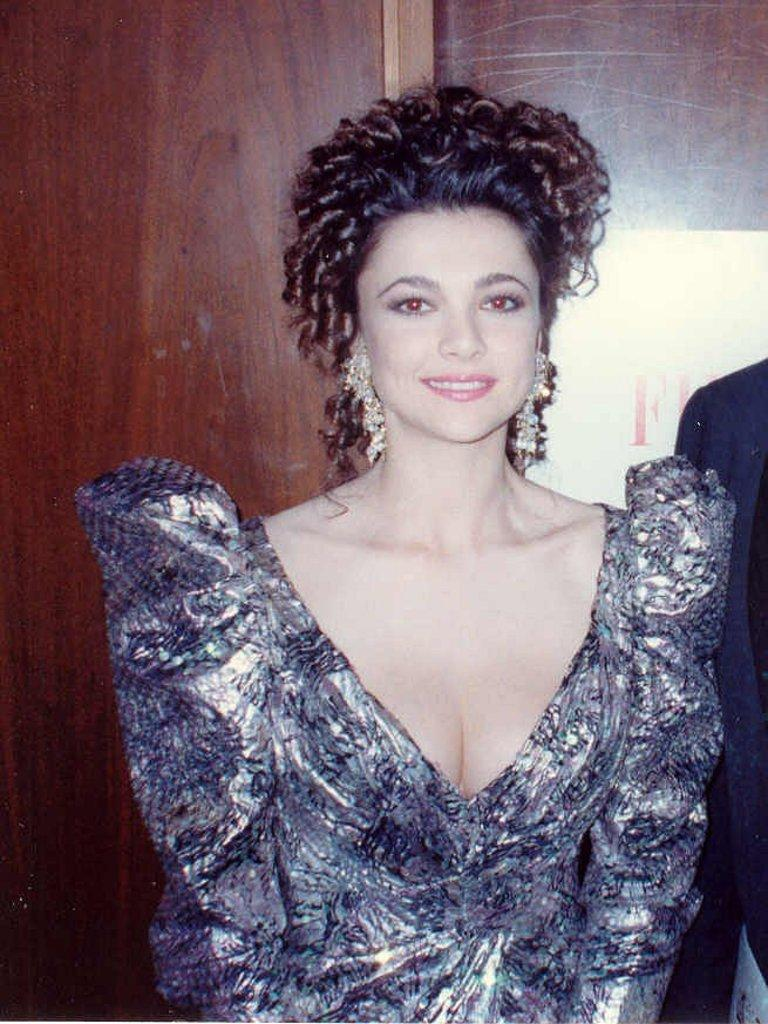Who or what is present in the image? A: There is a person in the image. What is the person wearing? The person is wearing a dress. What can be seen in the background of the image? There is a poster in the background of the image. What is the poster attached to? The poster is attached to a wooden wall. How many clovers are visible on the person's dress in the image? There are no clovers visible on the person's dress in the image. What is the person's income based on the image? There is no information about the person's income in the image. 